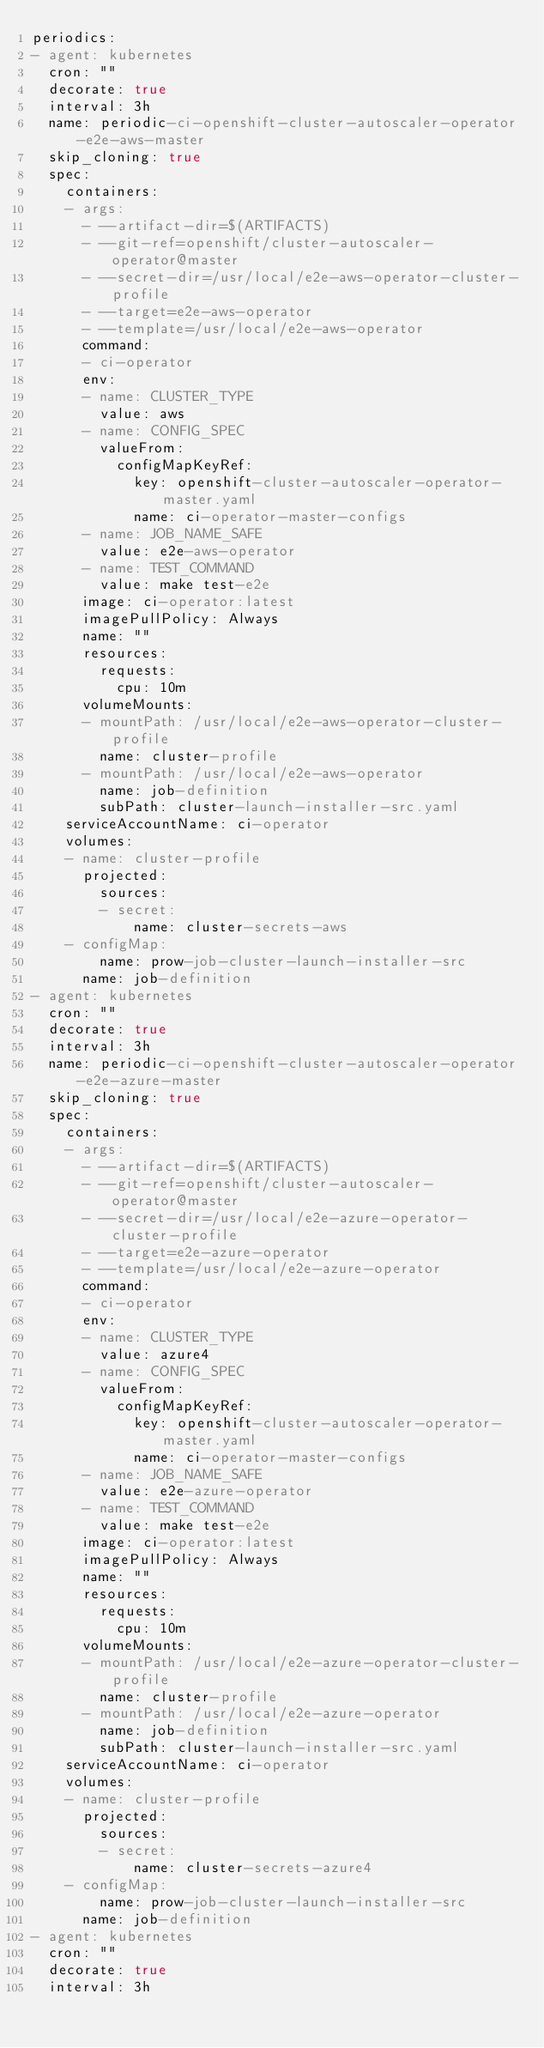Convert code to text. <code><loc_0><loc_0><loc_500><loc_500><_YAML_>periodics:
- agent: kubernetes
  cron: ""
  decorate: true
  interval: 3h
  name: periodic-ci-openshift-cluster-autoscaler-operator-e2e-aws-master
  skip_cloning: true
  spec:
    containers:
    - args:
      - --artifact-dir=$(ARTIFACTS)
      - --git-ref=openshift/cluster-autoscaler-operator@master
      - --secret-dir=/usr/local/e2e-aws-operator-cluster-profile
      - --target=e2e-aws-operator
      - --template=/usr/local/e2e-aws-operator
      command:
      - ci-operator
      env:
      - name: CLUSTER_TYPE
        value: aws
      - name: CONFIG_SPEC
        valueFrom:
          configMapKeyRef:
            key: openshift-cluster-autoscaler-operator-master.yaml
            name: ci-operator-master-configs
      - name: JOB_NAME_SAFE
        value: e2e-aws-operator
      - name: TEST_COMMAND
        value: make test-e2e
      image: ci-operator:latest
      imagePullPolicy: Always
      name: ""
      resources:
        requests:
          cpu: 10m
      volumeMounts:
      - mountPath: /usr/local/e2e-aws-operator-cluster-profile
        name: cluster-profile
      - mountPath: /usr/local/e2e-aws-operator
        name: job-definition
        subPath: cluster-launch-installer-src.yaml
    serviceAccountName: ci-operator
    volumes:
    - name: cluster-profile
      projected:
        sources:
        - secret:
            name: cluster-secrets-aws
    - configMap:
        name: prow-job-cluster-launch-installer-src
      name: job-definition
- agent: kubernetes
  cron: ""
  decorate: true
  interval: 3h
  name: periodic-ci-openshift-cluster-autoscaler-operator-e2e-azure-master
  skip_cloning: true
  spec:
    containers:
    - args:
      - --artifact-dir=$(ARTIFACTS)
      - --git-ref=openshift/cluster-autoscaler-operator@master
      - --secret-dir=/usr/local/e2e-azure-operator-cluster-profile
      - --target=e2e-azure-operator
      - --template=/usr/local/e2e-azure-operator
      command:
      - ci-operator
      env:
      - name: CLUSTER_TYPE
        value: azure4
      - name: CONFIG_SPEC
        valueFrom:
          configMapKeyRef:
            key: openshift-cluster-autoscaler-operator-master.yaml
            name: ci-operator-master-configs
      - name: JOB_NAME_SAFE
        value: e2e-azure-operator
      - name: TEST_COMMAND
        value: make test-e2e
      image: ci-operator:latest
      imagePullPolicy: Always
      name: ""
      resources:
        requests:
          cpu: 10m
      volumeMounts:
      - mountPath: /usr/local/e2e-azure-operator-cluster-profile
        name: cluster-profile
      - mountPath: /usr/local/e2e-azure-operator
        name: job-definition
        subPath: cluster-launch-installer-src.yaml
    serviceAccountName: ci-operator
    volumes:
    - name: cluster-profile
      projected:
        sources:
        - secret:
            name: cluster-secrets-azure4
    - configMap:
        name: prow-job-cluster-launch-installer-src
      name: job-definition
- agent: kubernetes
  cron: ""
  decorate: true
  interval: 3h</code> 